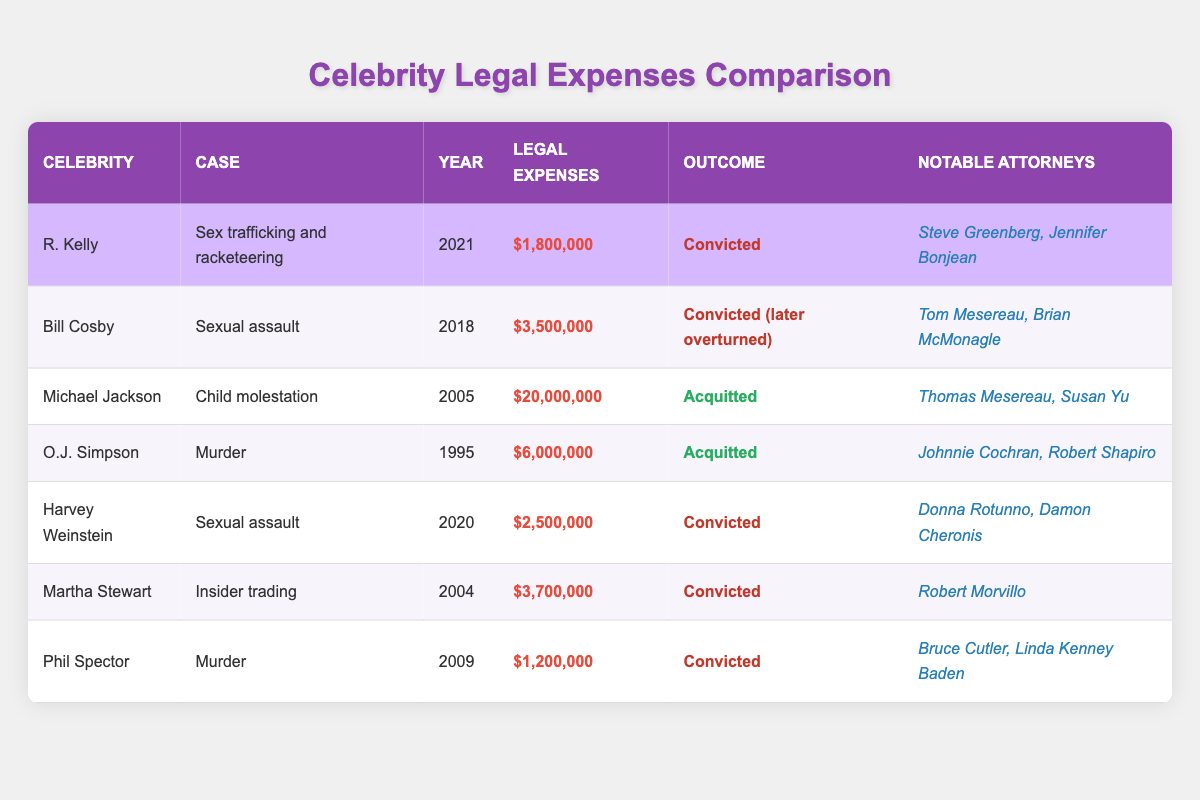What were R. Kelly's legal expenses? R. Kelly's legal expenses for the case of sex trafficking and racketeering in 2021 are listed in the table as $1,800,000.
Answer: $1,800,000 How many notable attorneys represented Bill Cosby? The table indicates that Bill Cosby had two notable attorneys: Tom Mesereau and Brian McMonagle.
Answer: 2 Which celebrity had the highest legal expenses? Based on the table, Michael Jackson's legal expenses of $20,000,000 for the child molestation case in 2005 are the highest compared to all others listed.
Answer: Michael Jackson What is the total amount of legal expenses for all celebrities combined? By summing all the legal expenses: $1,800,000 + $3,500,000 + $20,000,000 + $6,000,000 + $2,500,000 + $3,700,000 + $1,200,000 = $38,700,000, so the total amount is $38,700,000.
Answer: $38,700,000 Did Martha Stewart's case result in a conviction? According to the table, Martha Stewart was convicted in her insider trading case, as indicated in the outcome column.
Answer: Yes Which celebrity was acquitted but still had legal expenses over $1 million? The table shows that O.J. Simpson was acquitted in his murder case and had legal expenses of $6,000,000, which is over $1 million.
Answer: O.J. Simpson What was the year of the conviction for Harvey Weinstein? The table states that Harvey Weinstein was convicted in 2020.
Answer: 2020 Which two celebrities had legal expenses less than R. Kelly's? R. Kelly's legal expenses are $1,800,000. Both Phil Spector, with $1,200,000, and R. Kelly, with a higher initial figure, are less, as per the table. Therefore: Phil Spector and R. Kelly.
Answer: Phil Spector How many cases listed resulted in an acquittal? The table indicates that there are two cases resulting in acquittal: Michael Jackson and O.J. Simpson.
Answer: 2 